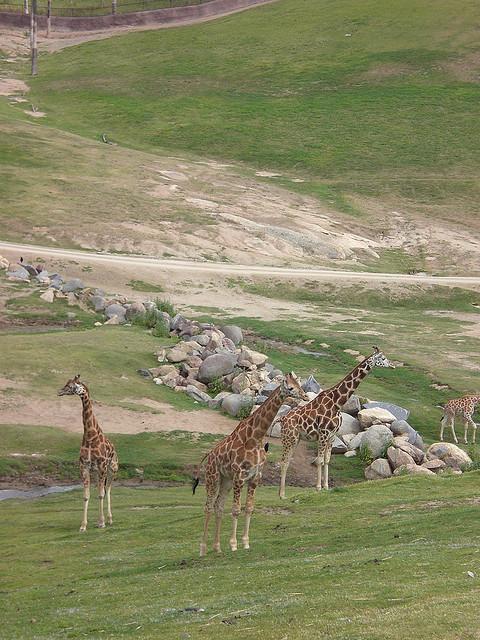How many animals are at this location?
Give a very brief answer. 4. How many giraffes can be seen?
Give a very brief answer. 3. 